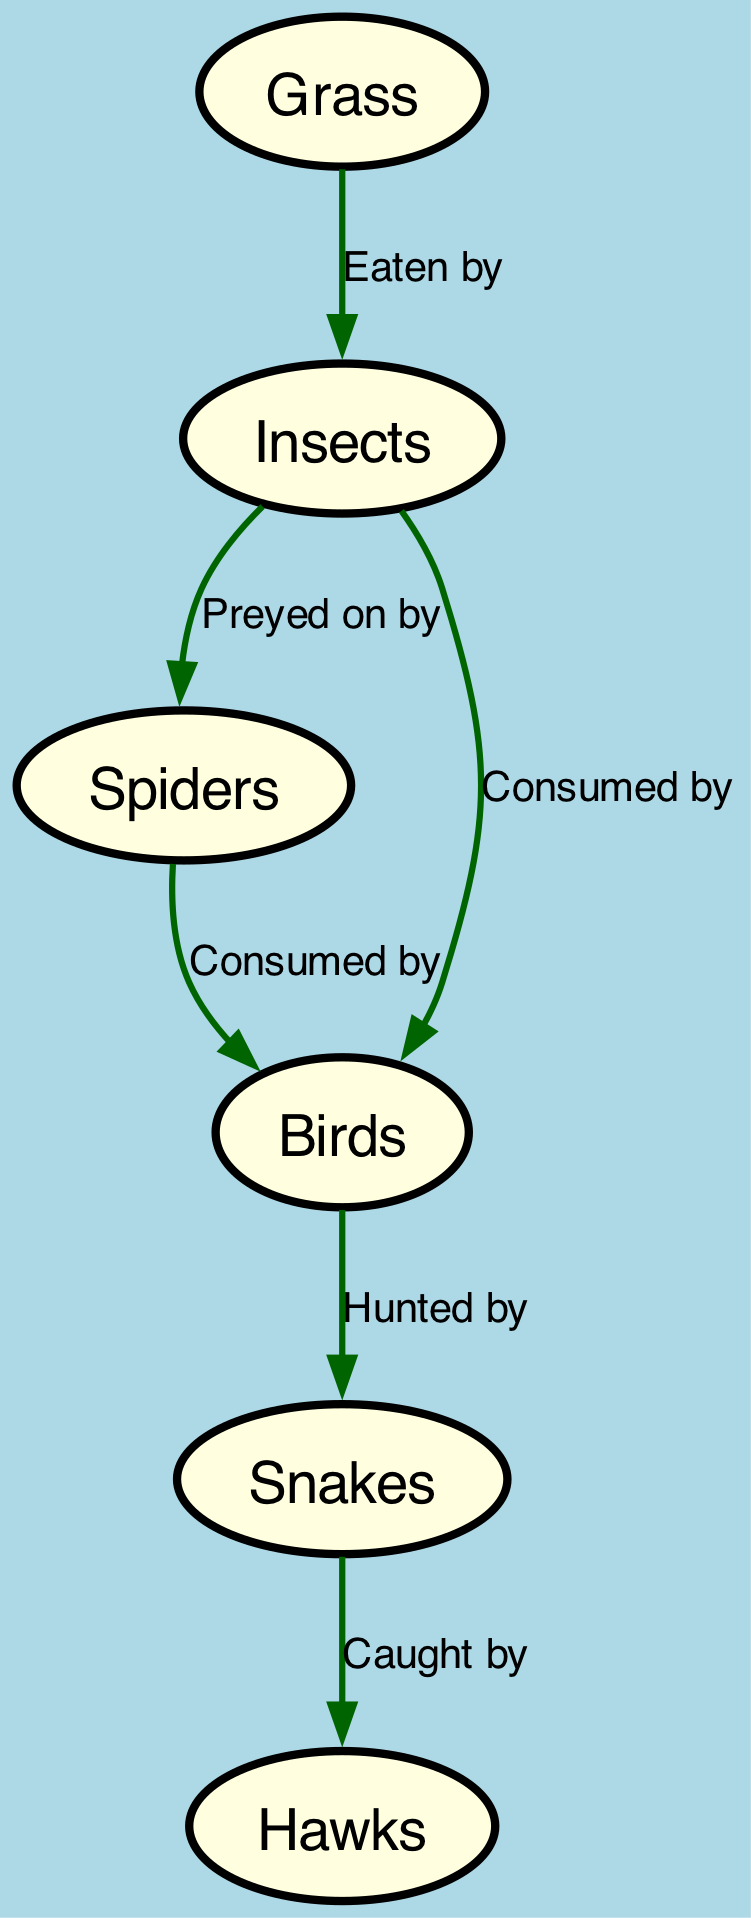What is the first node in the food chain? The first node in the food chain is "Grass," which serves as the primary producer in this ecosystem. This is determined by observing that it has no incoming edges, meaning it's not predated upon by any other node.
Answer: Grass How many different nodes are present in the diagram? The diagram contains a total of 6 different nodes, which are Grass, Insects, Spiders, Birds, Snakes, and Hawks. This can be confirmed by counting the distinct elements listed under the "nodes" section in the provided data.
Answer: 6 Which node is consumed by both insects and spiders? The node "Insects" is both preyed upon by Spiders and consumed by Birds. This is illustrated by the directed edges showing that both edges lead to the Insects node - one from Spiders and one from Birds.
Answer: Insects What relationship exists between birds and snakes? The relationship is that Birds are "Hunted by" Snakes. This can be seen by the directed edge from Birds to Snakes, where the label specifies the action of hunting.
Answer: Hunted by Which node is at the top of the food chain? The top of the food chain is represented by the node "Hawks," indicating that they are the apex predator in this ecosystem. This is evident since there are no edges leading out from the Hawks, meaning they are not predated upon.
Answer: Hawks How many edges connect to the insects? There are three edges that connect to the Insects node. This includes edges coming from Grass (eaten by), and edges leading to Spiders (preyed on by) and Birds (consumed by). The total can be counted from the edges specified in the data.
Answer: 3 Which organism primarily feeds on grass? The organism that primarily feeds on Grass is "Insects." This is indicated by the edge labeled "Eaten by" directing from Grass to Insects.
Answer: Insects What is the relationship between snakes and hawks? The relationship is that Snakes are "Caught by" Hawks. This is shown by the directed edge which specifies the action of being caught, illustrating the predator-prey relationship.
Answer: Caught by 